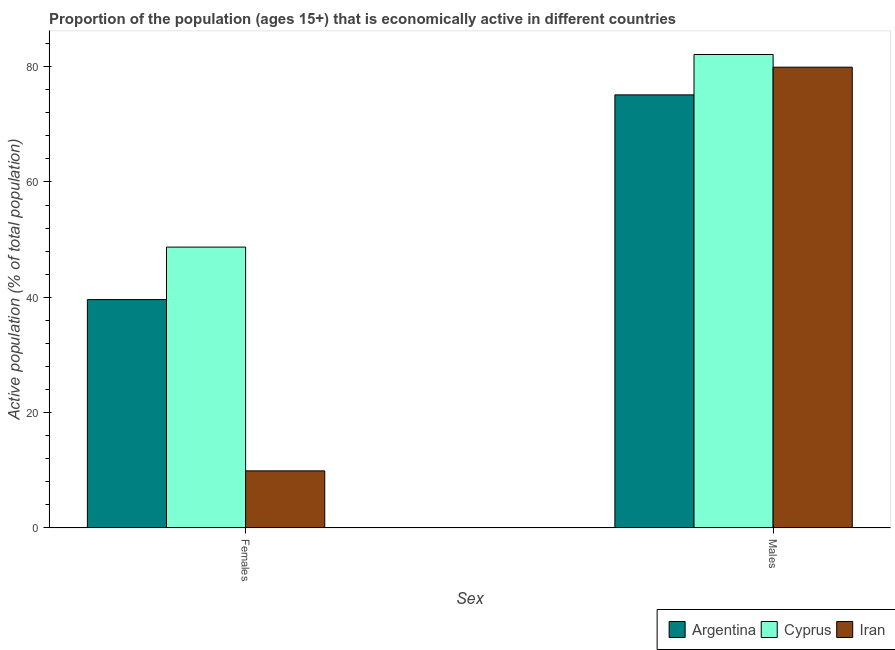Are the number of bars per tick equal to the number of legend labels?
Your answer should be very brief. Yes. Are the number of bars on each tick of the X-axis equal?
Keep it short and to the point. Yes. How many bars are there on the 2nd tick from the left?
Provide a short and direct response. 3. How many bars are there on the 2nd tick from the right?
Make the answer very short. 3. What is the label of the 2nd group of bars from the left?
Give a very brief answer. Males. What is the percentage of economically active female population in Cyprus?
Your answer should be very brief. 48.7. Across all countries, what is the maximum percentage of economically active male population?
Ensure brevity in your answer.  82.1. Across all countries, what is the minimum percentage of economically active female population?
Your answer should be very brief. 9.9. In which country was the percentage of economically active male population maximum?
Offer a very short reply. Cyprus. In which country was the percentage of economically active female population minimum?
Keep it short and to the point. Iran. What is the total percentage of economically active male population in the graph?
Your response must be concise. 237.1. What is the difference between the percentage of economically active female population in Cyprus and that in Argentina?
Ensure brevity in your answer.  9.1. What is the difference between the percentage of economically active female population in Iran and the percentage of economically active male population in Argentina?
Provide a short and direct response. -65.2. What is the average percentage of economically active female population per country?
Ensure brevity in your answer.  32.73. What is the difference between the percentage of economically active male population and percentage of economically active female population in Argentina?
Provide a short and direct response. 35.5. What is the ratio of the percentage of economically active female population in Cyprus to that in Iran?
Offer a very short reply. 4.92. In how many countries, is the percentage of economically active male population greater than the average percentage of economically active male population taken over all countries?
Your answer should be very brief. 2. What does the 1st bar from the left in Males represents?
Provide a short and direct response. Argentina. What does the 1st bar from the right in Females represents?
Keep it short and to the point. Iran. Are all the bars in the graph horizontal?
Your response must be concise. No. How many countries are there in the graph?
Your answer should be compact. 3. Are the values on the major ticks of Y-axis written in scientific E-notation?
Provide a short and direct response. No. Does the graph contain grids?
Offer a very short reply. No. Where does the legend appear in the graph?
Ensure brevity in your answer.  Bottom right. How are the legend labels stacked?
Offer a terse response. Horizontal. What is the title of the graph?
Provide a succinct answer. Proportion of the population (ages 15+) that is economically active in different countries. What is the label or title of the X-axis?
Your response must be concise. Sex. What is the label or title of the Y-axis?
Your answer should be compact. Active population (% of total population). What is the Active population (% of total population) in Argentina in Females?
Provide a short and direct response. 39.6. What is the Active population (% of total population) of Cyprus in Females?
Provide a short and direct response. 48.7. What is the Active population (% of total population) of Iran in Females?
Ensure brevity in your answer.  9.9. What is the Active population (% of total population) in Argentina in Males?
Provide a short and direct response. 75.1. What is the Active population (% of total population) of Cyprus in Males?
Your response must be concise. 82.1. What is the Active population (% of total population) of Iran in Males?
Your answer should be compact. 79.9. Across all Sex, what is the maximum Active population (% of total population) of Argentina?
Give a very brief answer. 75.1. Across all Sex, what is the maximum Active population (% of total population) in Cyprus?
Provide a succinct answer. 82.1. Across all Sex, what is the maximum Active population (% of total population) of Iran?
Keep it short and to the point. 79.9. Across all Sex, what is the minimum Active population (% of total population) of Argentina?
Your response must be concise. 39.6. Across all Sex, what is the minimum Active population (% of total population) in Cyprus?
Your answer should be very brief. 48.7. Across all Sex, what is the minimum Active population (% of total population) of Iran?
Offer a terse response. 9.9. What is the total Active population (% of total population) of Argentina in the graph?
Provide a short and direct response. 114.7. What is the total Active population (% of total population) in Cyprus in the graph?
Offer a terse response. 130.8. What is the total Active population (% of total population) in Iran in the graph?
Ensure brevity in your answer.  89.8. What is the difference between the Active population (% of total population) in Argentina in Females and that in Males?
Your response must be concise. -35.5. What is the difference between the Active population (% of total population) in Cyprus in Females and that in Males?
Ensure brevity in your answer.  -33.4. What is the difference between the Active population (% of total population) of Iran in Females and that in Males?
Your answer should be very brief. -70. What is the difference between the Active population (% of total population) of Argentina in Females and the Active population (% of total population) of Cyprus in Males?
Give a very brief answer. -42.5. What is the difference between the Active population (% of total population) of Argentina in Females and the Active population (% of total population) of Iran in Males?
Make the answer very short. -40.3. What is the difference between the Active population (% of total population) of Cyprus in Females and the Active population (% of total population) of Iran in Males?
Provide a short and direct response. -31.2. What is the average Active population (% of total population) of Argentina per Sex?
Offer a terse response. 57.35. What is the average Active population (% of total population) of Cyprus per Sex?
Provide a succinct answer. 65.4. What is the average Active population (% of total population) of Iran per Sex?
Provide a short and direct response. 44.9. What is the difference between the Active population (% of total population) in Argentina and Active population (% of total population) in Iran in Females?
Provide a succinct answer. 29.7. What is the difference between the Active population (% of total population) of Cyprus and Active population (% of total population) of Iran in Females?
Make the answer very short. 38.8. What is the difference between the Active population (% of total population) of Argentina and Active population (% of total population) of Cyprus in Males?
Provide a short and direct response. -7. What is the difference between the Active population (% of total population) in Cyprus and Active population (% of total population) in Iran in Males?
Make the answer very short. 2.2. What is the ratio of the Active population (% of total population) of Argentina in Females to that in Males?
Provide a succinct answer. 0.53. What is the ratio of the Active population (% of total population) in Cyprus in Females to that in Males?
Your answer should be very brief. 0.59. What is the ratio of the Active population (% of total population) of Iran in Females to that in Males?
Make the answer very short. 0.12. What is the difference between the highest and the second highest Active population (% of total population) of Argentina?
Your response must be concise. 35.5. What is the difference between the highest and the second highest Active population (% of total population) of Cyprus?
Ensure brevity in your answer.  33.4. What is the difference between the highest and the lowest Active population (% of total population) of Argentina?
Offer a terse response. 35.5. What is the difference between the highest and the lowest Active population (% of total population) of Cyprus?
Your answer should be compact. 33.4. 